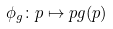<formula> <loc_0><loc_0><loc_500><loc_500>\phi _ { g } \colon p \mapsto p g ( p )</formula> 